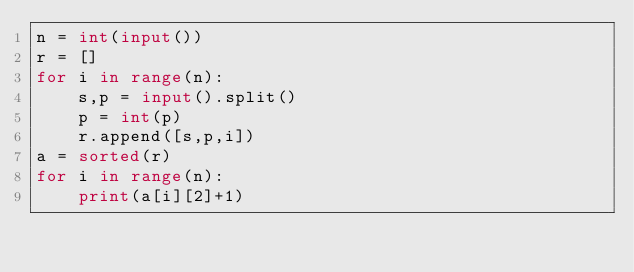<code> <loc_0><loc_0><loc_500><loc_500><_Python_>n = int(input())
r = []
for i in range(n):
    s,p = input().split()
    p = int(p)
    r.append([s,p,i])
a = sorted(r)
for i in range(n):
    print(a[i][2]+1)</code> 